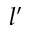<formula> <loc_0><loc_0><loc_500><loc_500>l ^ { \prime }</formula> 